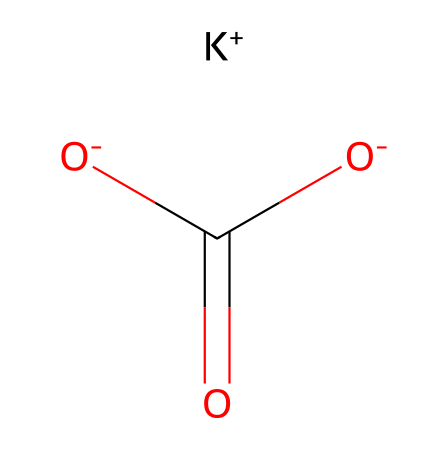How many oxygen atoms are present in potassium bicarbonate? In the given SMILES representation, we can identify the components of the molecule. The part [O-]C(=O) indicates that there are two oxygen atoms in the carboxylate group, and there is one additional oxygen atom in the bicarbonate part, which makes a total of three oxygen atoms.
Answer: three What is the overall charge of potassium bicarbonate in this representation? The SMILES shows [K+], which indicates a positive charge, and there are two negative charges from the two [O-] groups. This results in an overall neutral charge for the molecule (1 positive + 2 negative = neutral).
Answer: neutral What type of functional groups are present in potassium bicarbonate? The molecule contains a carboxylate group (-COO-) as indicated by the arrangement of the oxygen and carbon atoms, which is typical for bicarbonates.
Answer: carboxylate group What is the total number of carbon atoms in potassium bicarbonate? Looking at the SMILES representation, we note there is one carbon atom present in the structure, which can be observed in the (C) of the carbonyl and the carboxylate group.
Answer: one How does potassium bicarbonate dissociate in solution? This compound dissociates into potassium ions (K+) and bicarbonate ions (HCO3-) in an aqueous environment. Upon dissolving, it separates into its constituent ions, thus functioning as an electrolyte.
Answer: into potassium ions and bicarbonate ions What is the role of potassium in potassium bicarbonate? The potassium ion serves as a cation that balances the negative charges from the bicarbonate part, providing the electrolyte properties necessary for various biological and chemical processes.
Answer: to balance negative charges 